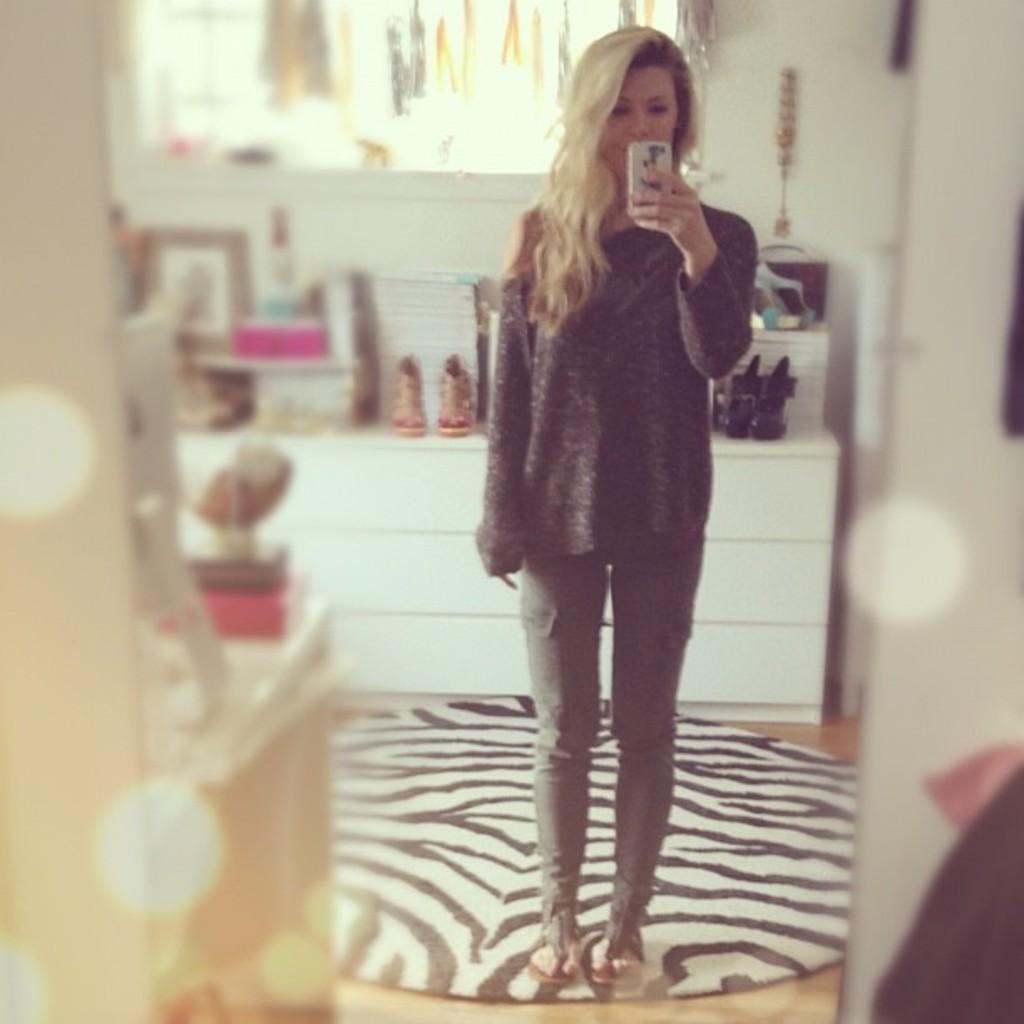Describe this image in one or two sentences. In the center of the image there is a woman standing on the floor holding a mobile phone. In the background there are objects, shoes, photo frames, wall and window. 